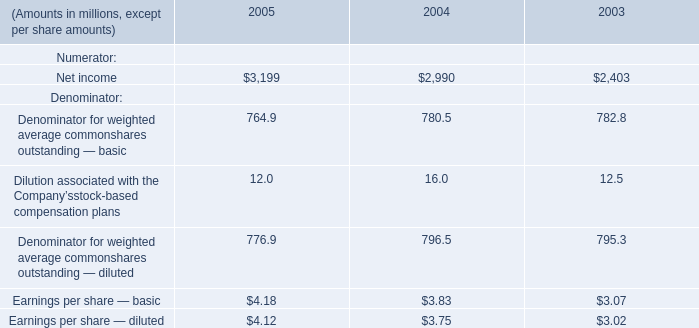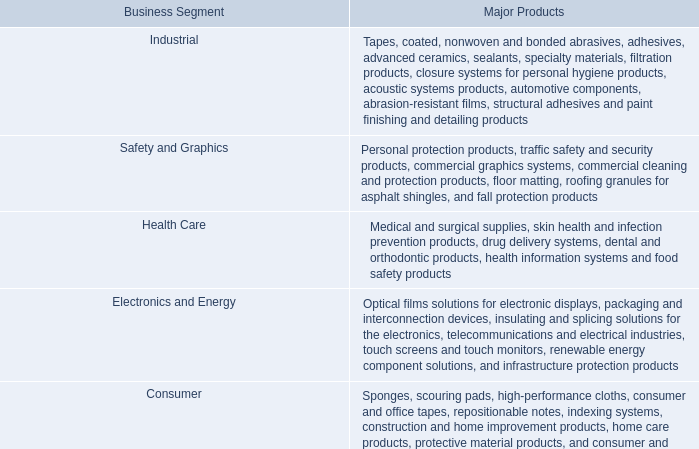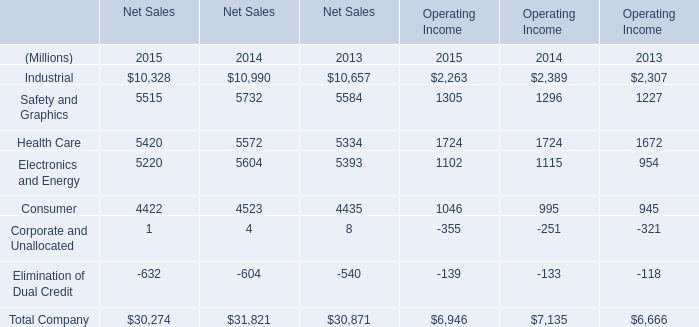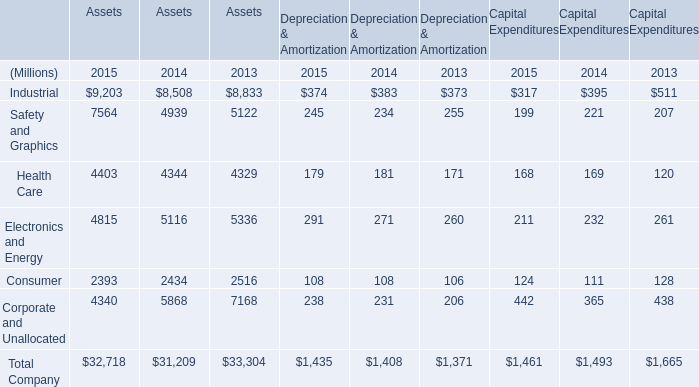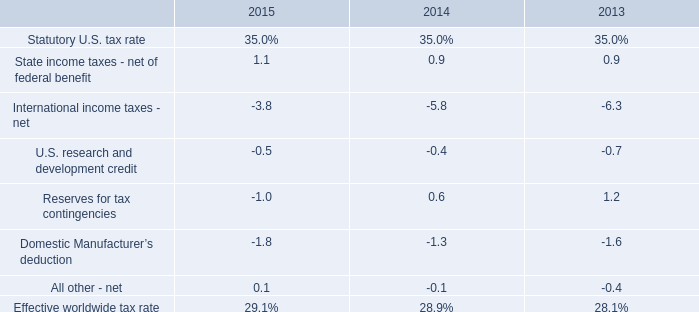What is the sum of Net income of 2003, Electronics and Energy of Net Sales 2015, and Total Company of Assets 2014 ? 
Computations: ((2403.0 + 5220.0) + 31209.0)
Answer: 38832.0. 